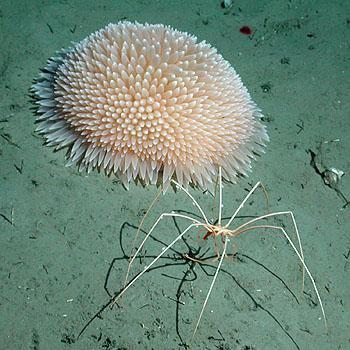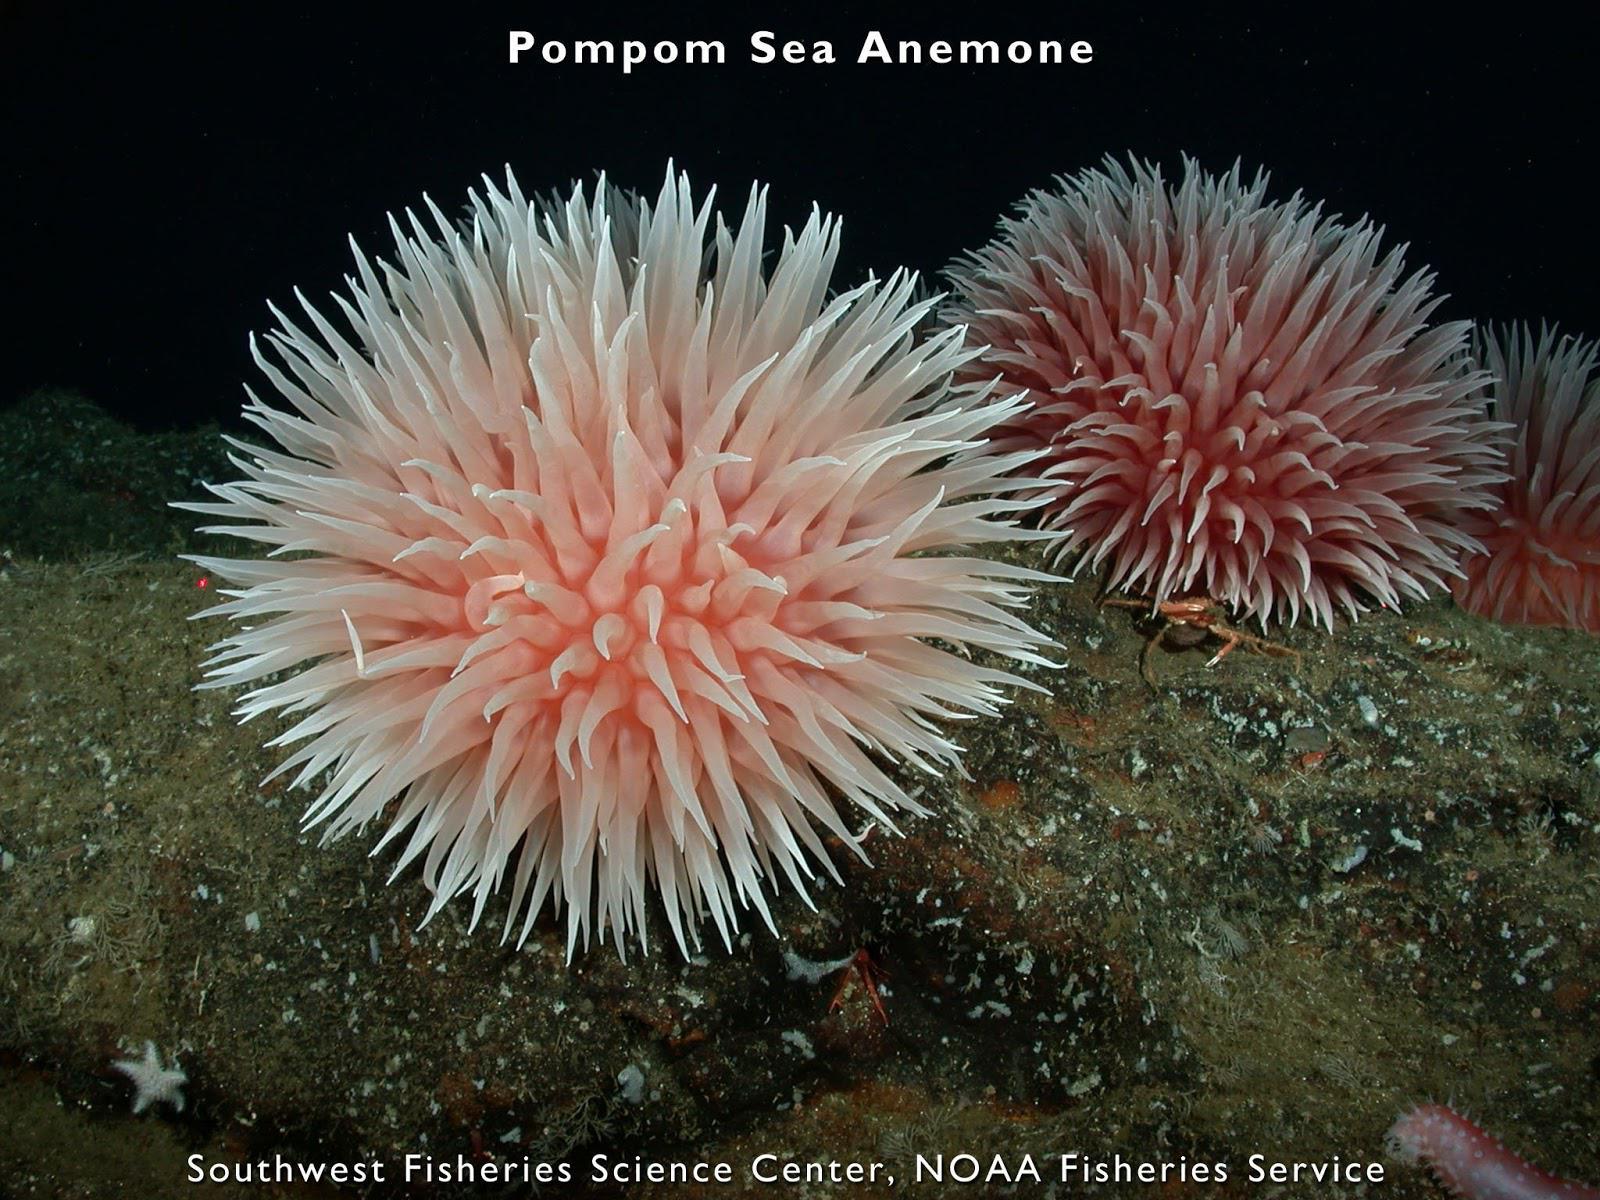The first image is the image on the left, the second image is the image on the right. For the images displayed, is the sentence "Right image shows two flower-shaped anemones." factually correct? Answer yes or no. Yes. The first image is the image on the left, the second image is the image on the right. Evaluate the accuracy of this statement regarding the images: "There are two anemones in the image on the right.". Is it true? Answer yes or no. Yes. 